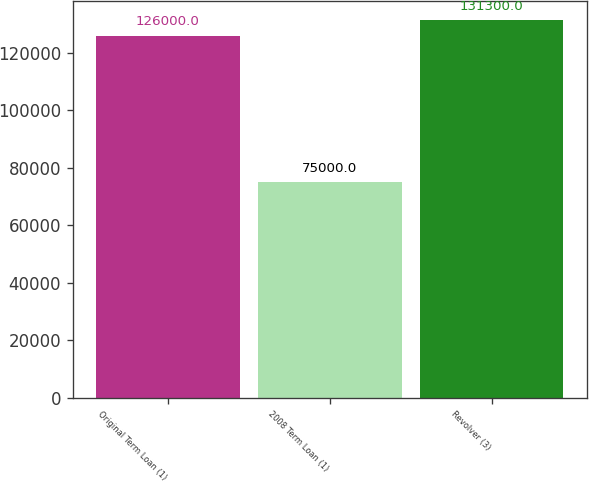Convert chart. <chart><loc_0><loc_0><loc_500><loc_500><bar_chart><fcel>Original Term Loan (1)<fcel>2008 Term Loan (1)<fcel>Revolver (3)<nl><fcel>126000<fcel>75000<fcel>131300<nl></chart> 